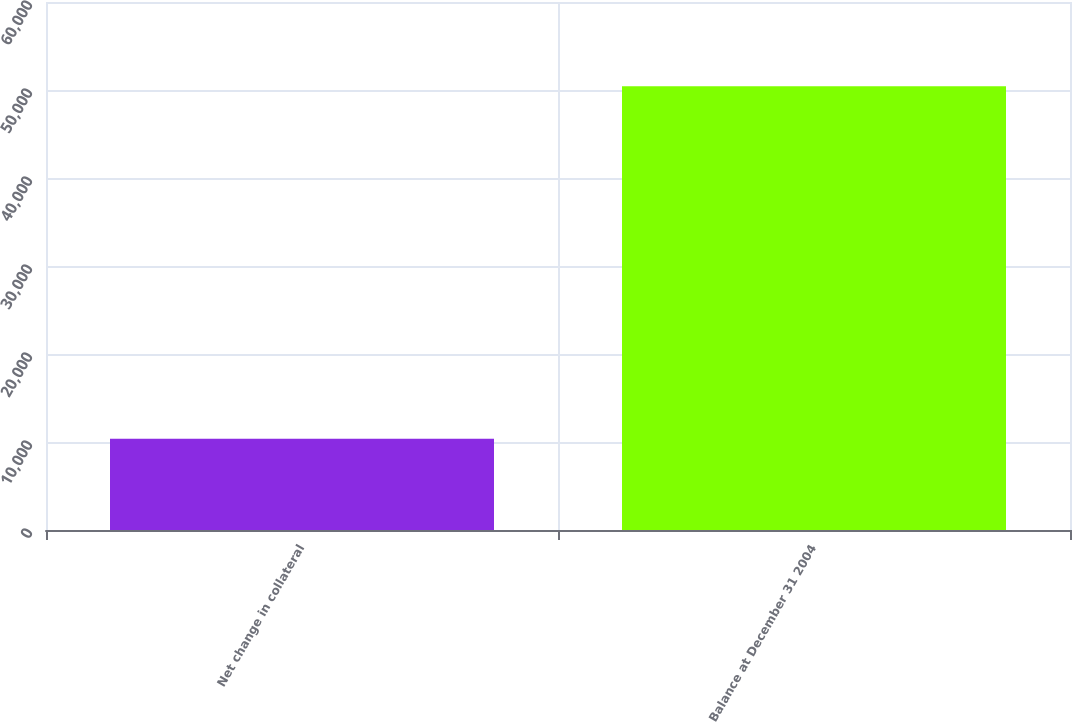Convert chart. <chart><loc_0><loc_0><loc_500><loc_500><bar_chart><fcel>Net change in collateral<fcel>Balance at December 31 2004<nl><fcel>10383<fcel>50416<nl></chart> 